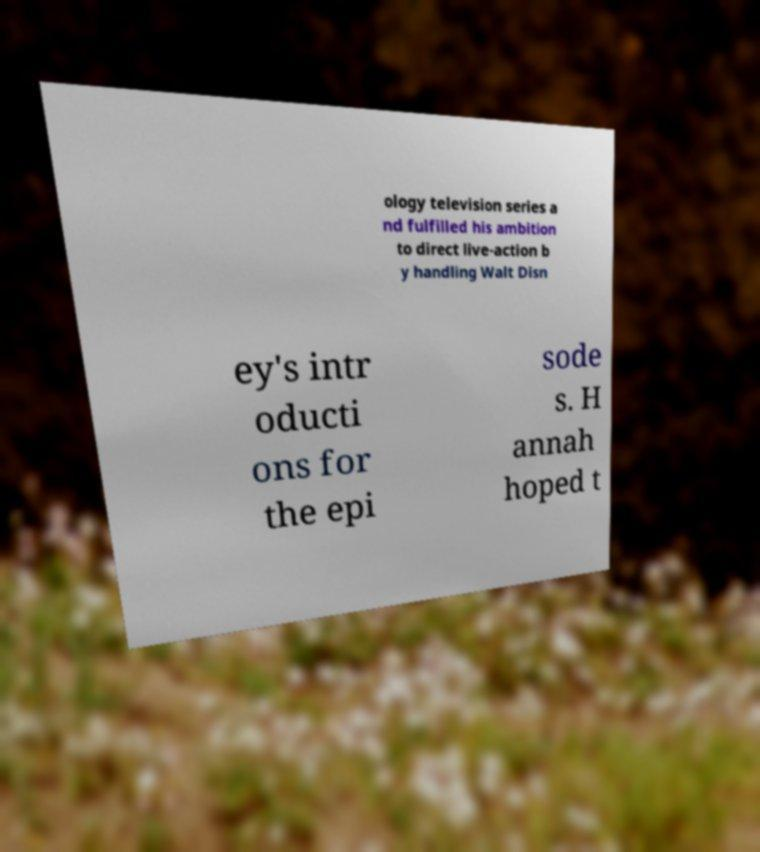I need the written content from this picture converted into text. Can you do that? ology television series a nd fulfilled his ambition to direct live-action b y handling Walt Disn ey's intr oducti ons for the epi sode s. H annah hoped t 